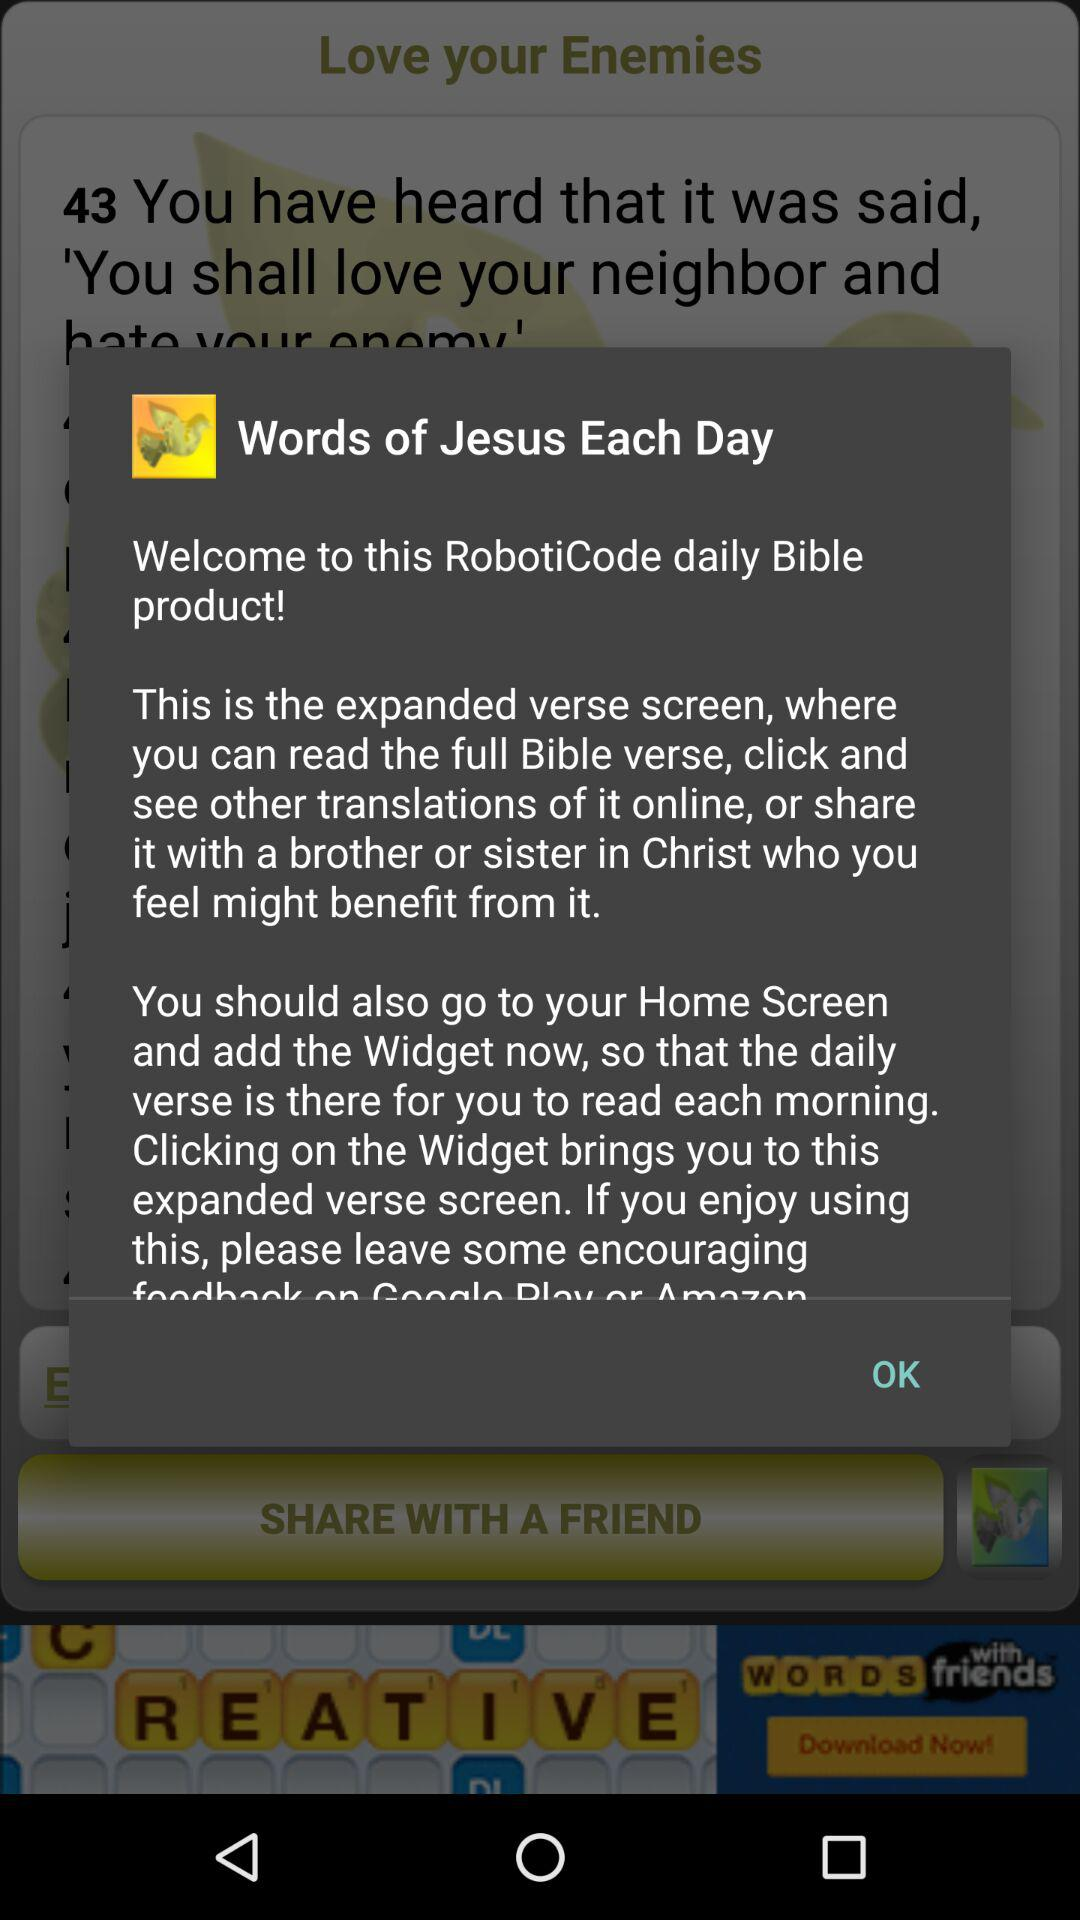What is the name of the application? The name of the application is "Words of Jesus Each Day". 